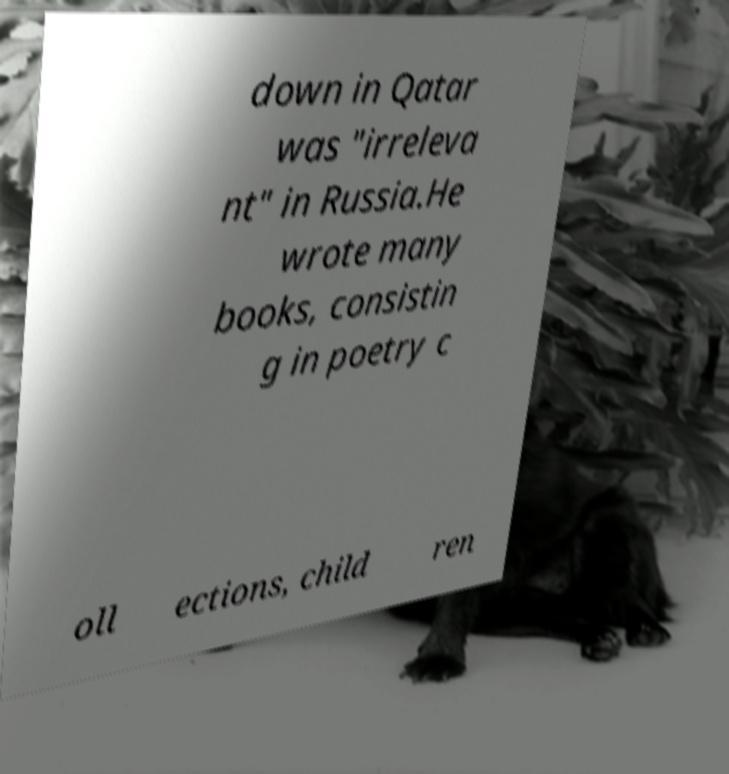Can you accurately transcribe the text from the provided image for me? down in Qatar was "irreleva nt" in Russia.He wrote many books, consistin g in poetry c oll ections, child ren 